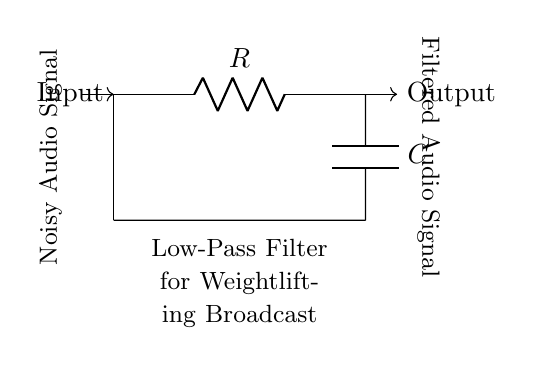What is the type of filter in this circuit? This circuit is a low-pass filter, as indicated by its name and the arrangement of its components. In a low-pass filter, signals below a certain frequency can pass through while higher frequencies are attenuated.
Answer: low-pass filter What components are used in this circuit? The components used in this circuit are a resistor denoted by R and a capacitor denoted by C. The combination of these two components defines the behavior of the low-pass filter.
Answer: resistor and capacitor What direction is the audio signal flowing? The audio signal flows from the input on the left through the resistor and capacitor, and exits at the output on the right. The arrows show the direction of the flow, indicating how the signal is processed.
Answer: left to right What is the purpose of the capacitor in this circuit? The capacitor in a low-pass filter serves to block high-frequency signals and allow low-frequency signals to pass, effectively smoothing out the noisy audio signals to produce a clearer sound.
Answer: to block high-frequency signals What does the label "Noisy Audio Signal" represent? The label "Noisy Audio Signal" represents the type of input signal being fed into the filter, which contains undesirable noise that needs to be reduced to improve audio quality during broadcasts.
Answer: input signal with noise What effect does the resistor have on the circuit? The resistor controls the charging and discharging of the capacitor, thus influencing the cutoff frequency of the filter. A higher resistance increases the time constant, leading to a lower cutoff frequency and a stronger attenuation of unwanted frequencies.
Answer: controls the cutoff frequency At which point is the filtered audio signal taken? The filtered audio signal is taken from the output node to the right of the capacitor. This is where the low frequencies have passed through while high frequencies have been attenuated.
Answer: the output node 